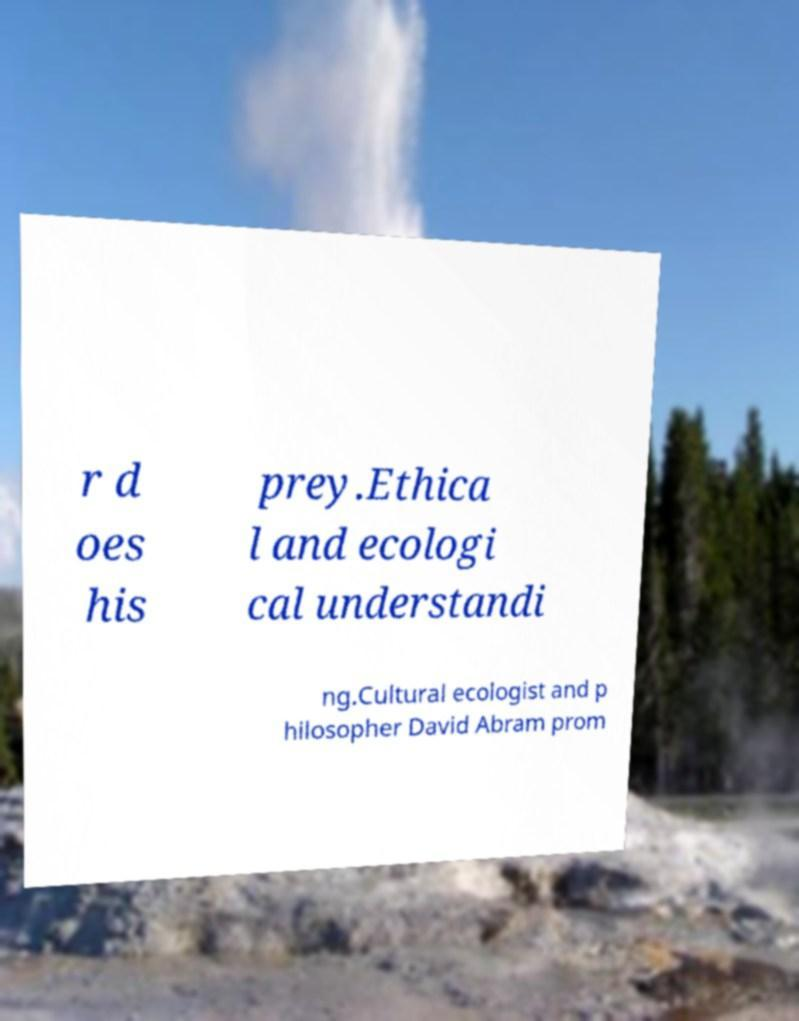There's text embedded in this image that I need extracted. Can you transcribe it verbatim? r d oes his prey.Ethica l and ecologi cal understandi ng.Cultural ecologist and p hilosopher David Abram prom 